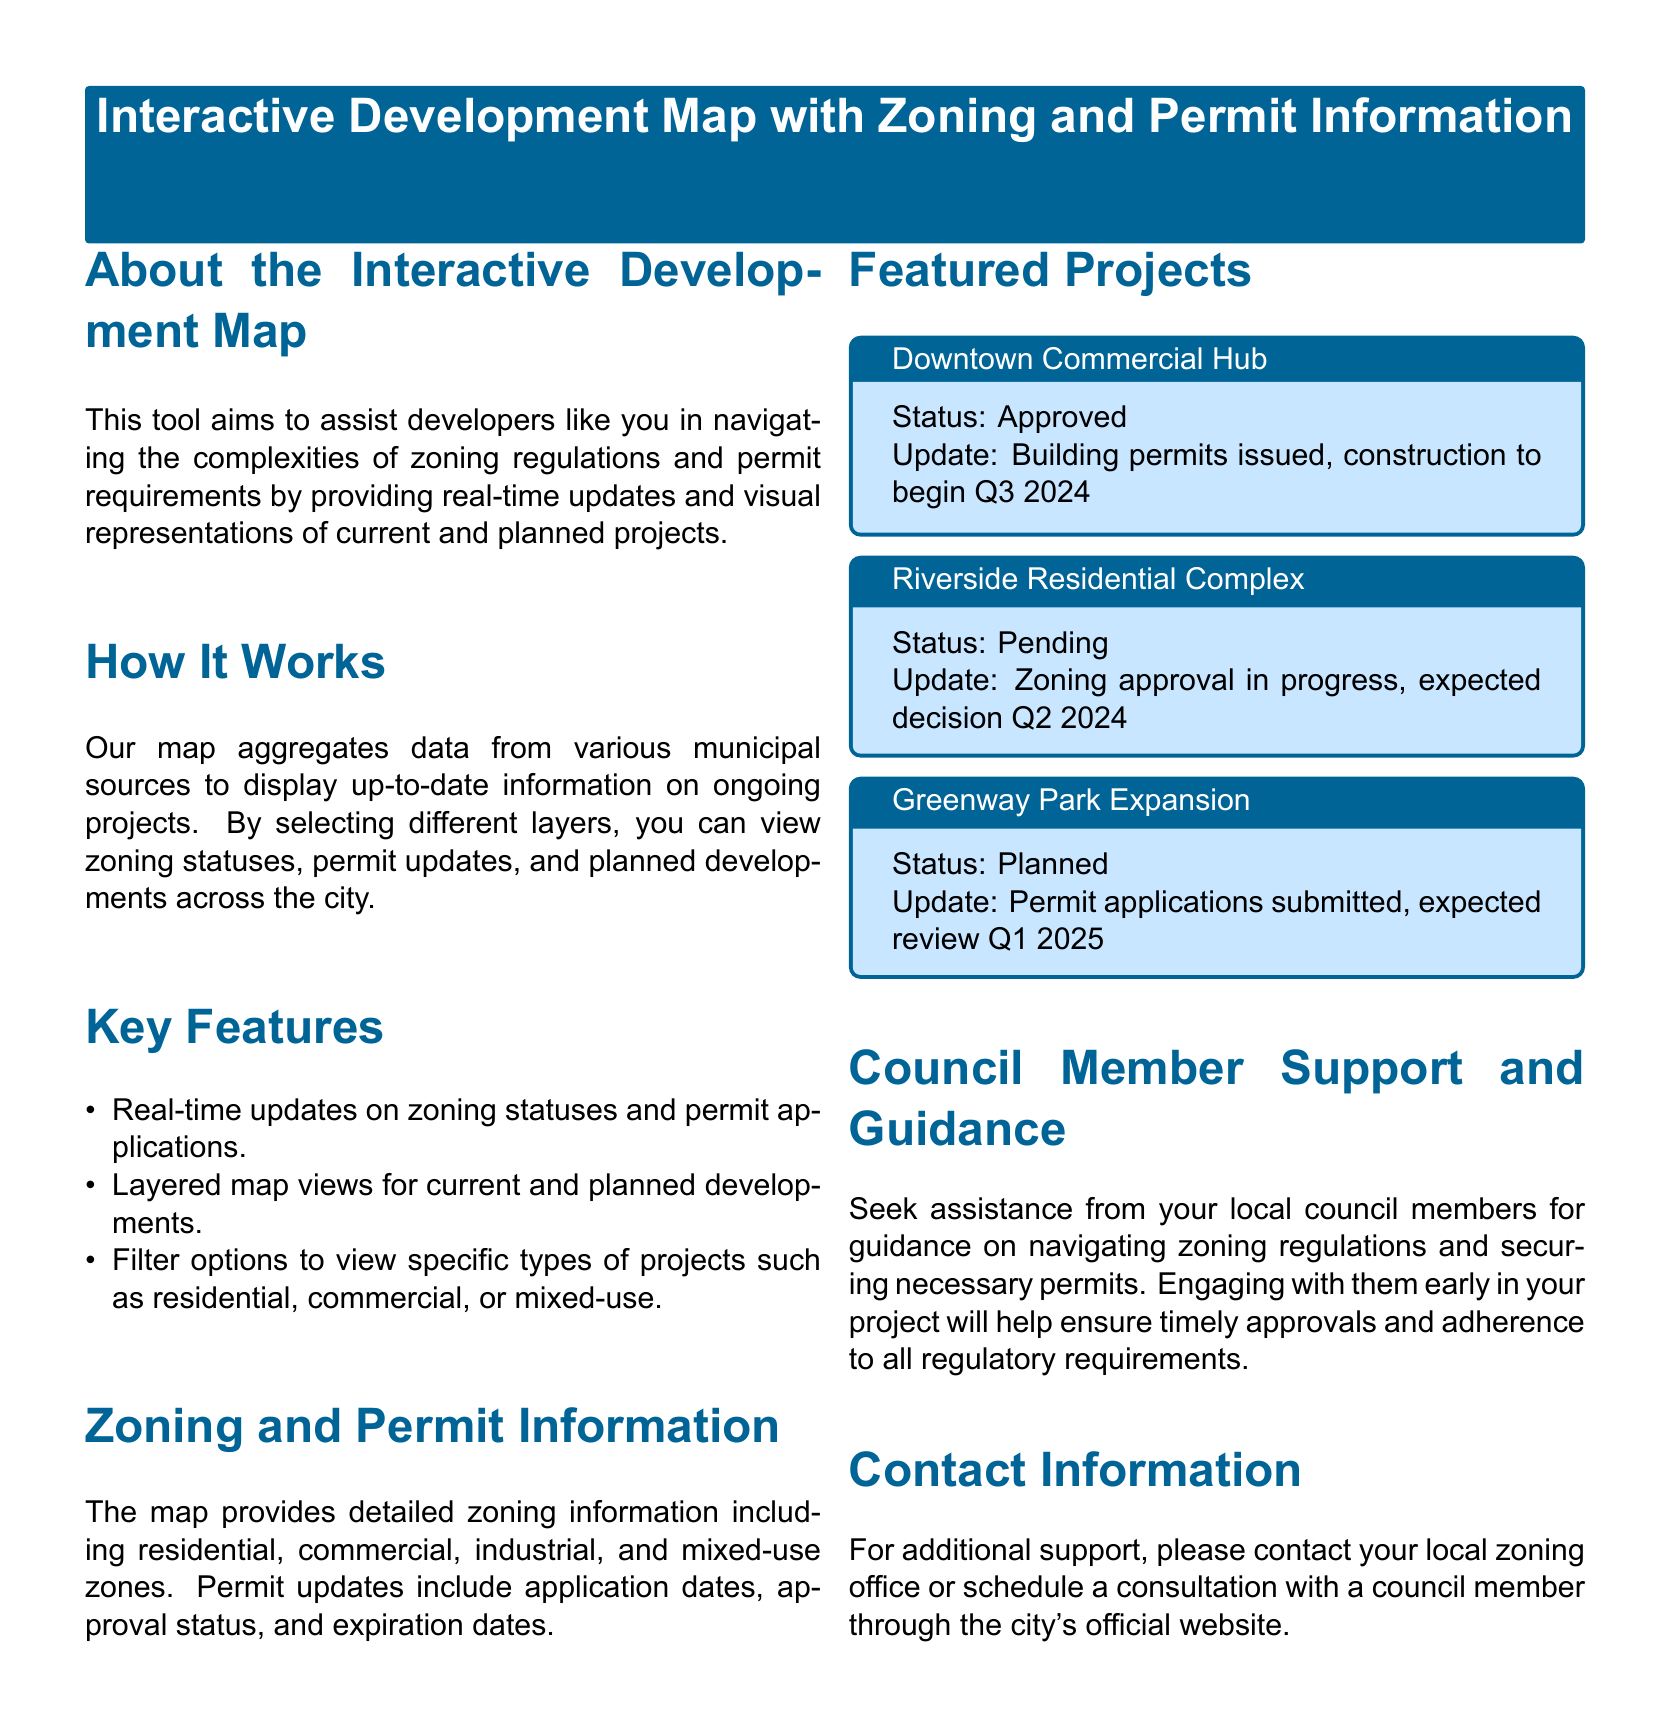what is the title of the document? The title is presented at the top of the document within a colored box.
Answer: Interactive Development Map with Zoning and Permit Information what type of projects can you filter for on the map? The document lists specific types of projects that can be filtered on the map.
Answer: residential, commercial, or mixed-use what is the status of the Downtown Commercial Hub? The status is listed as part of the featured projects section.
Answer: Approved when is construction expected to begin for the Downtown Commercial Hub? The document provides an update on the construction timeline for this project.
Answer: Q3 2024 what is the status of the Riverside Residential Complex? This information is found in a dedicated box for featured projects.
Answer: Pending when is the decision expected for the Riverside Residential Complex zoning approval? The document indicates when the expected decision will be made.
Answer: Q2 2024 what information can the map provide about zoning? The document mentions the specific types of zoning information available.
Answer: residential, commercial, industrial, and mixed-use zones how can developers seek assistance regarding zoning regulations? The document suggests a method for developers to obtain help with zoning.
Answer: Contact local council members 